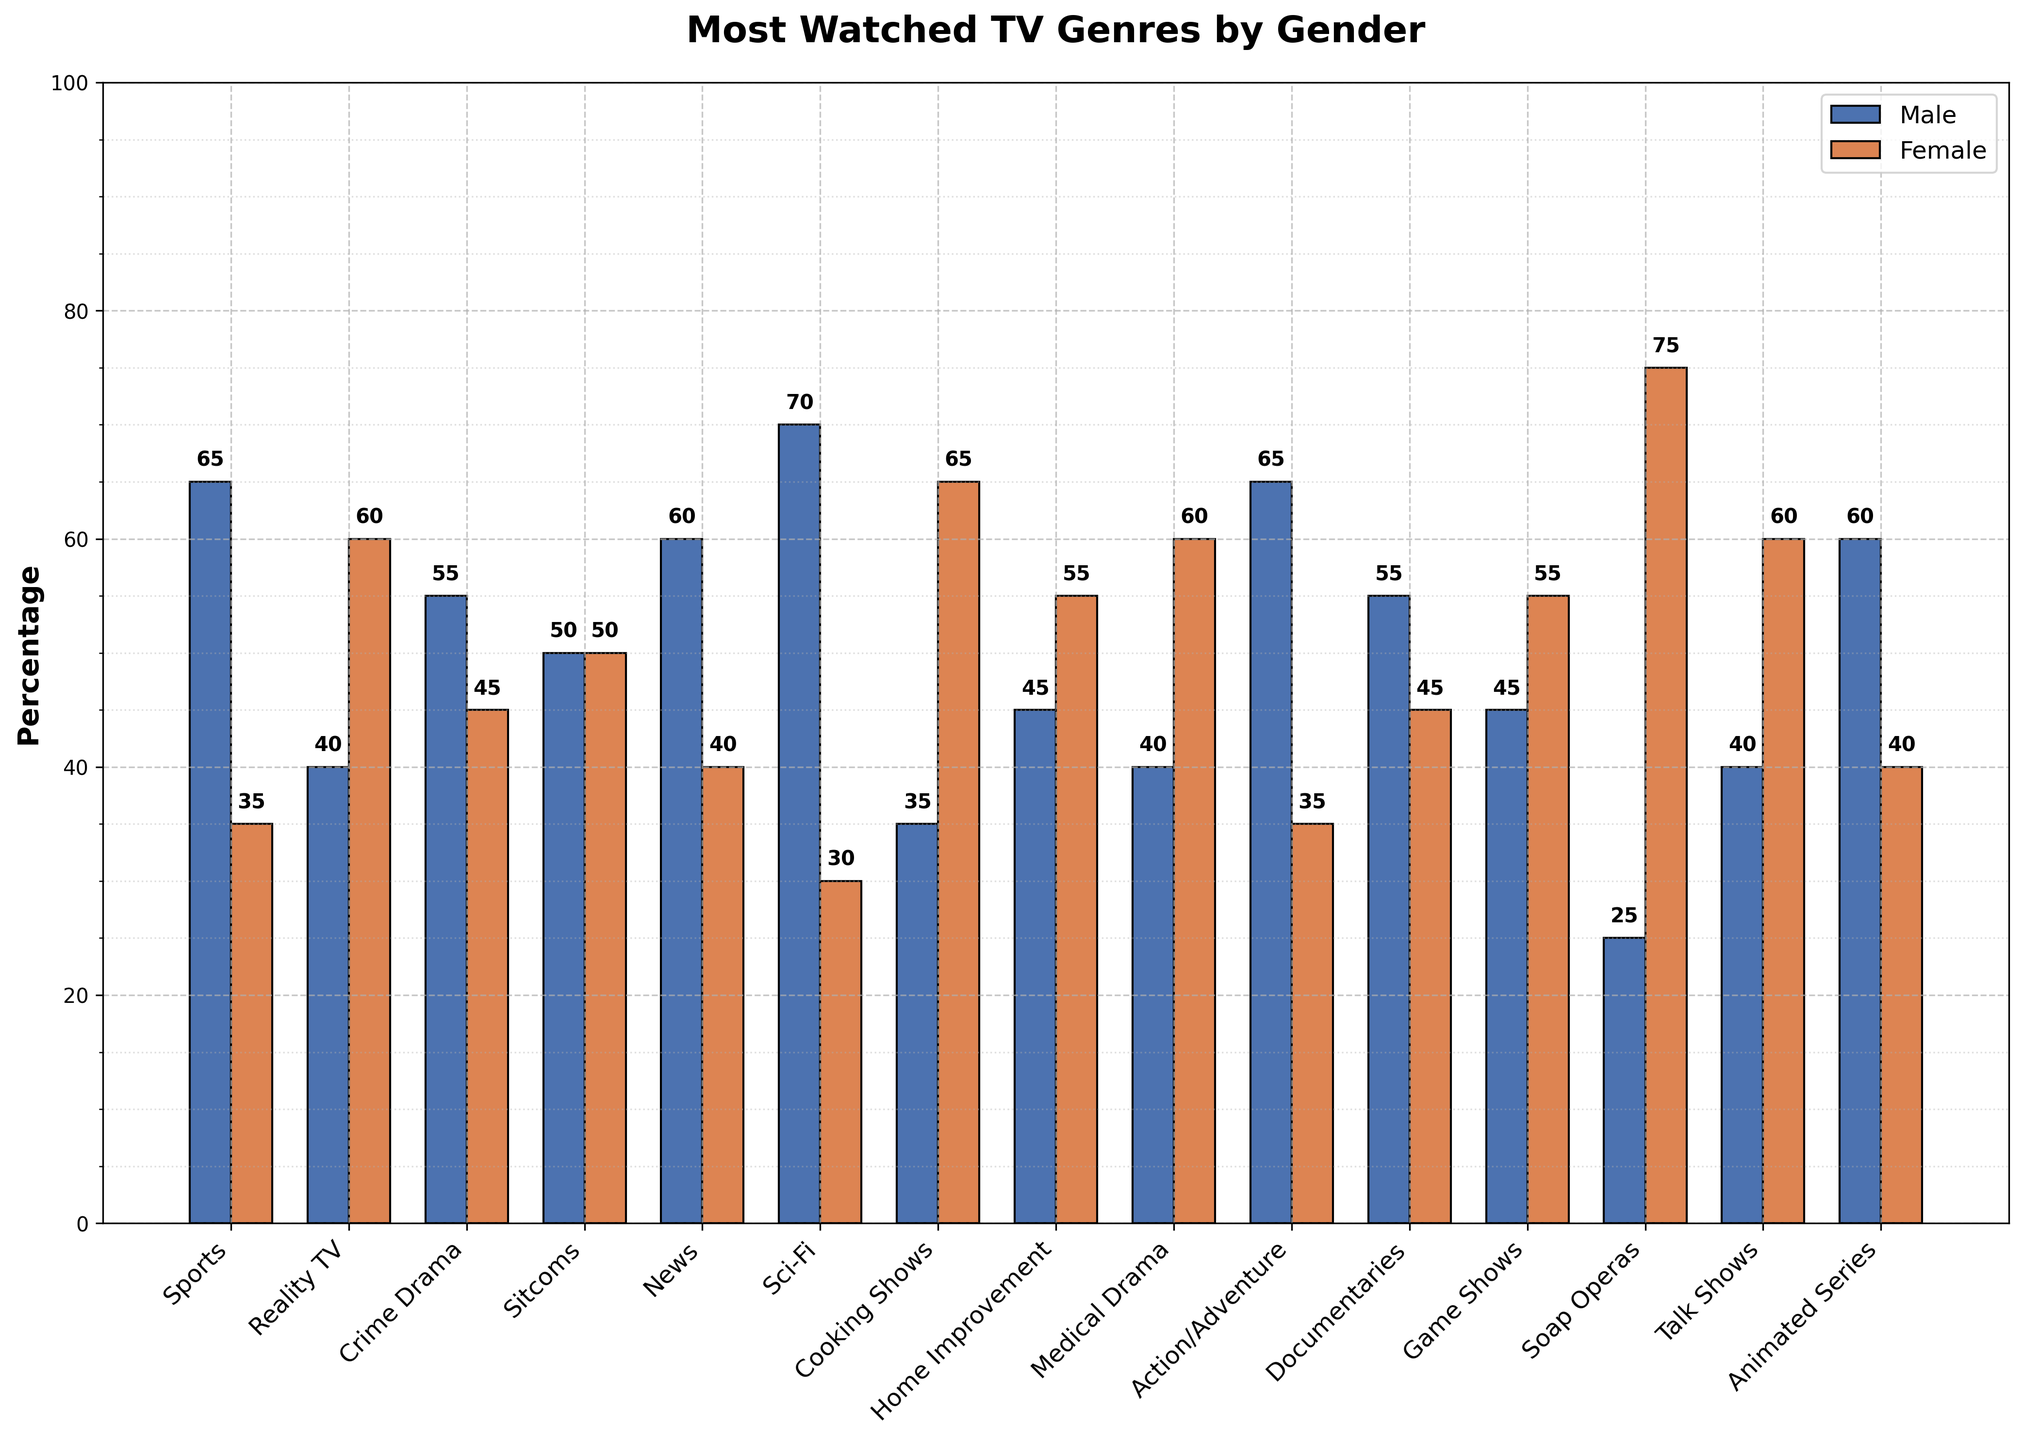Which genre is most popular among males? Look for the tallest bar in the "Male" category. The tallest bar for males corresponds to Sci-Fi, which is 70%.
Answer: Sci-Fi What's the difference in popularity between Sports and Cooking Shows among males? The percentage for Sports among males is 65%, and for Cooking Shows, it is 35%. The difference is 65% - 35% = 30%.
Answer: 30% Which genre has the highest female viewership? Look for the tallest bar in the "Female" category. The tallest bar for females corresponds to Soap Operas, which is 75%.
Answer: Soap Operas How does the popularity of Action/Adventure compare between males and females? Compare the heights of the bars for Action/Adventure. The bar for males is 65%, and the bar for females is 35%. Males have a higher viewership.
Answer: Males have a higher viewership Which genre has equal viewership among males and females? Look for bars of equal height in the "Male" and "Female" categories. Sitcoms have bars of equal height, each at 50%.
Answer: Sitcoms What is the average female percentage for Reality TV and Medical Drama? The percentage for Reality TV among females is 60%, and for Medical Drama, it is also 60%. The average is (60% + 60%) / 2 = 60%.
Answer: 60% Which genres have a higher viewership among females than males? Compare the bars for each genre. The genres where the female bar is taller than the male bar are Reality TV, Cooking Shows, Home Improvement, Medical Drama, Soap Operas, and Talk Shows.
Answer: Reality TV, Cooking Shows, Home Improvement, Medical Drama, Soap Operas, Talk Shows What is the combined percentage of male viewers for Documentaries and News? The percentage for Documentaries among males is 55%, and for News, it is 60%. The combined percentage is 55% + 60% = 115%.
Answer: 115% Which genre shows a 50-50 viewership split between males and females? Find the genre where both bars are equal. This happens at Sitcoms with bars at 50% each.
Answer: Sitcoms What is the total percentage difference between male and female viewers for Animated Series? The percentage for Animated Series among males is 60%, and for females, it is 40%. The difference is 60% - 40% = 20%.
Answer: 20% 